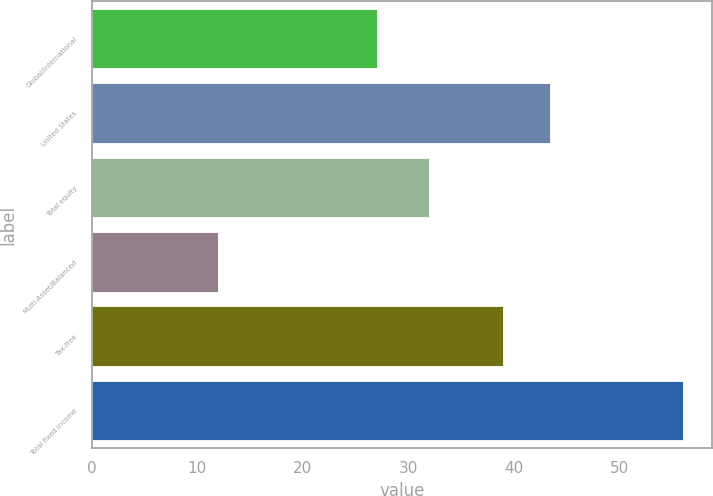Convert chart to OTSL. <chart><loc_0><loc_0><loc_500><loc_500><bar_chart><fcel>Global/international<fcel>United States<fcel>Total equity<fcel>Multi-Asset/Balanced<fcel>Tax-free<fcel>Total fixed income<nl><fcel>27<fcel>43.4<fcel>32<fcel>12<fcel>39<fcel>56<nl></chart> 